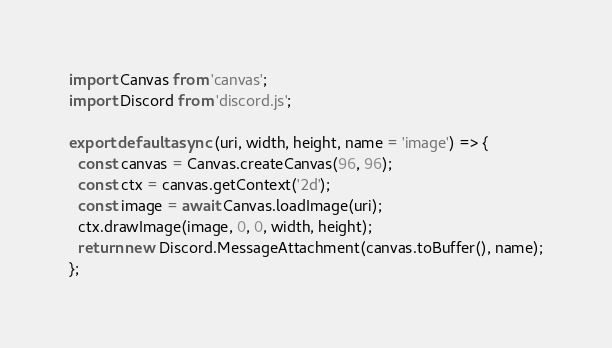Convert code to text. <code><loc_0><loc_0><loc_500><loc_500><_JavaScript_>import Canvas from 'canvas';
import Discord from 'discord.js';

export default async (uri, width, height, name = 'image') => {
  const canvas = Canvas.createCanvas(96, 96);
  const ctx = canvas.getContext('2d');
  const image = await Canvas.loadImage(uri);
  ctx.drawImage(image, 0, 0, width, height);
  return new Discord.MessageAttachment(canvas.toBuffer(), name);
};
</code> 